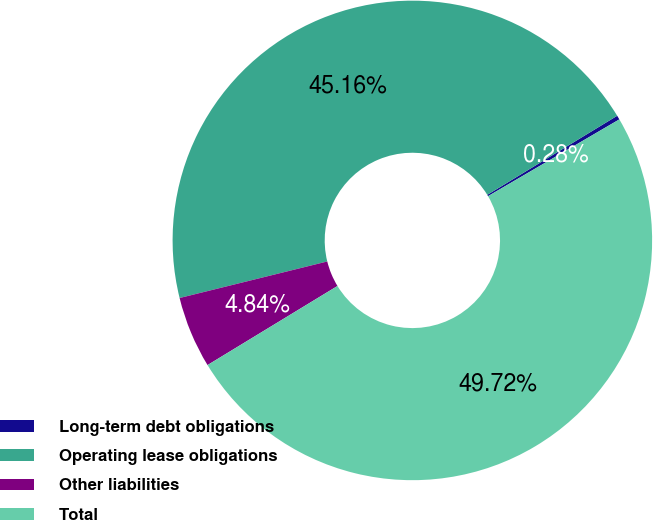<chart> <loc_0><loc_0><loc_500><loc_500><pie_chart><fcel>Long-term debt obligations<fcel>Operating lease obligations<fcel>Other liabilities<fcel>Total<nl><fcel>0.28%<fcel>45.16%<fcel>4.84%<fcel>49.72%<nl></chart> 